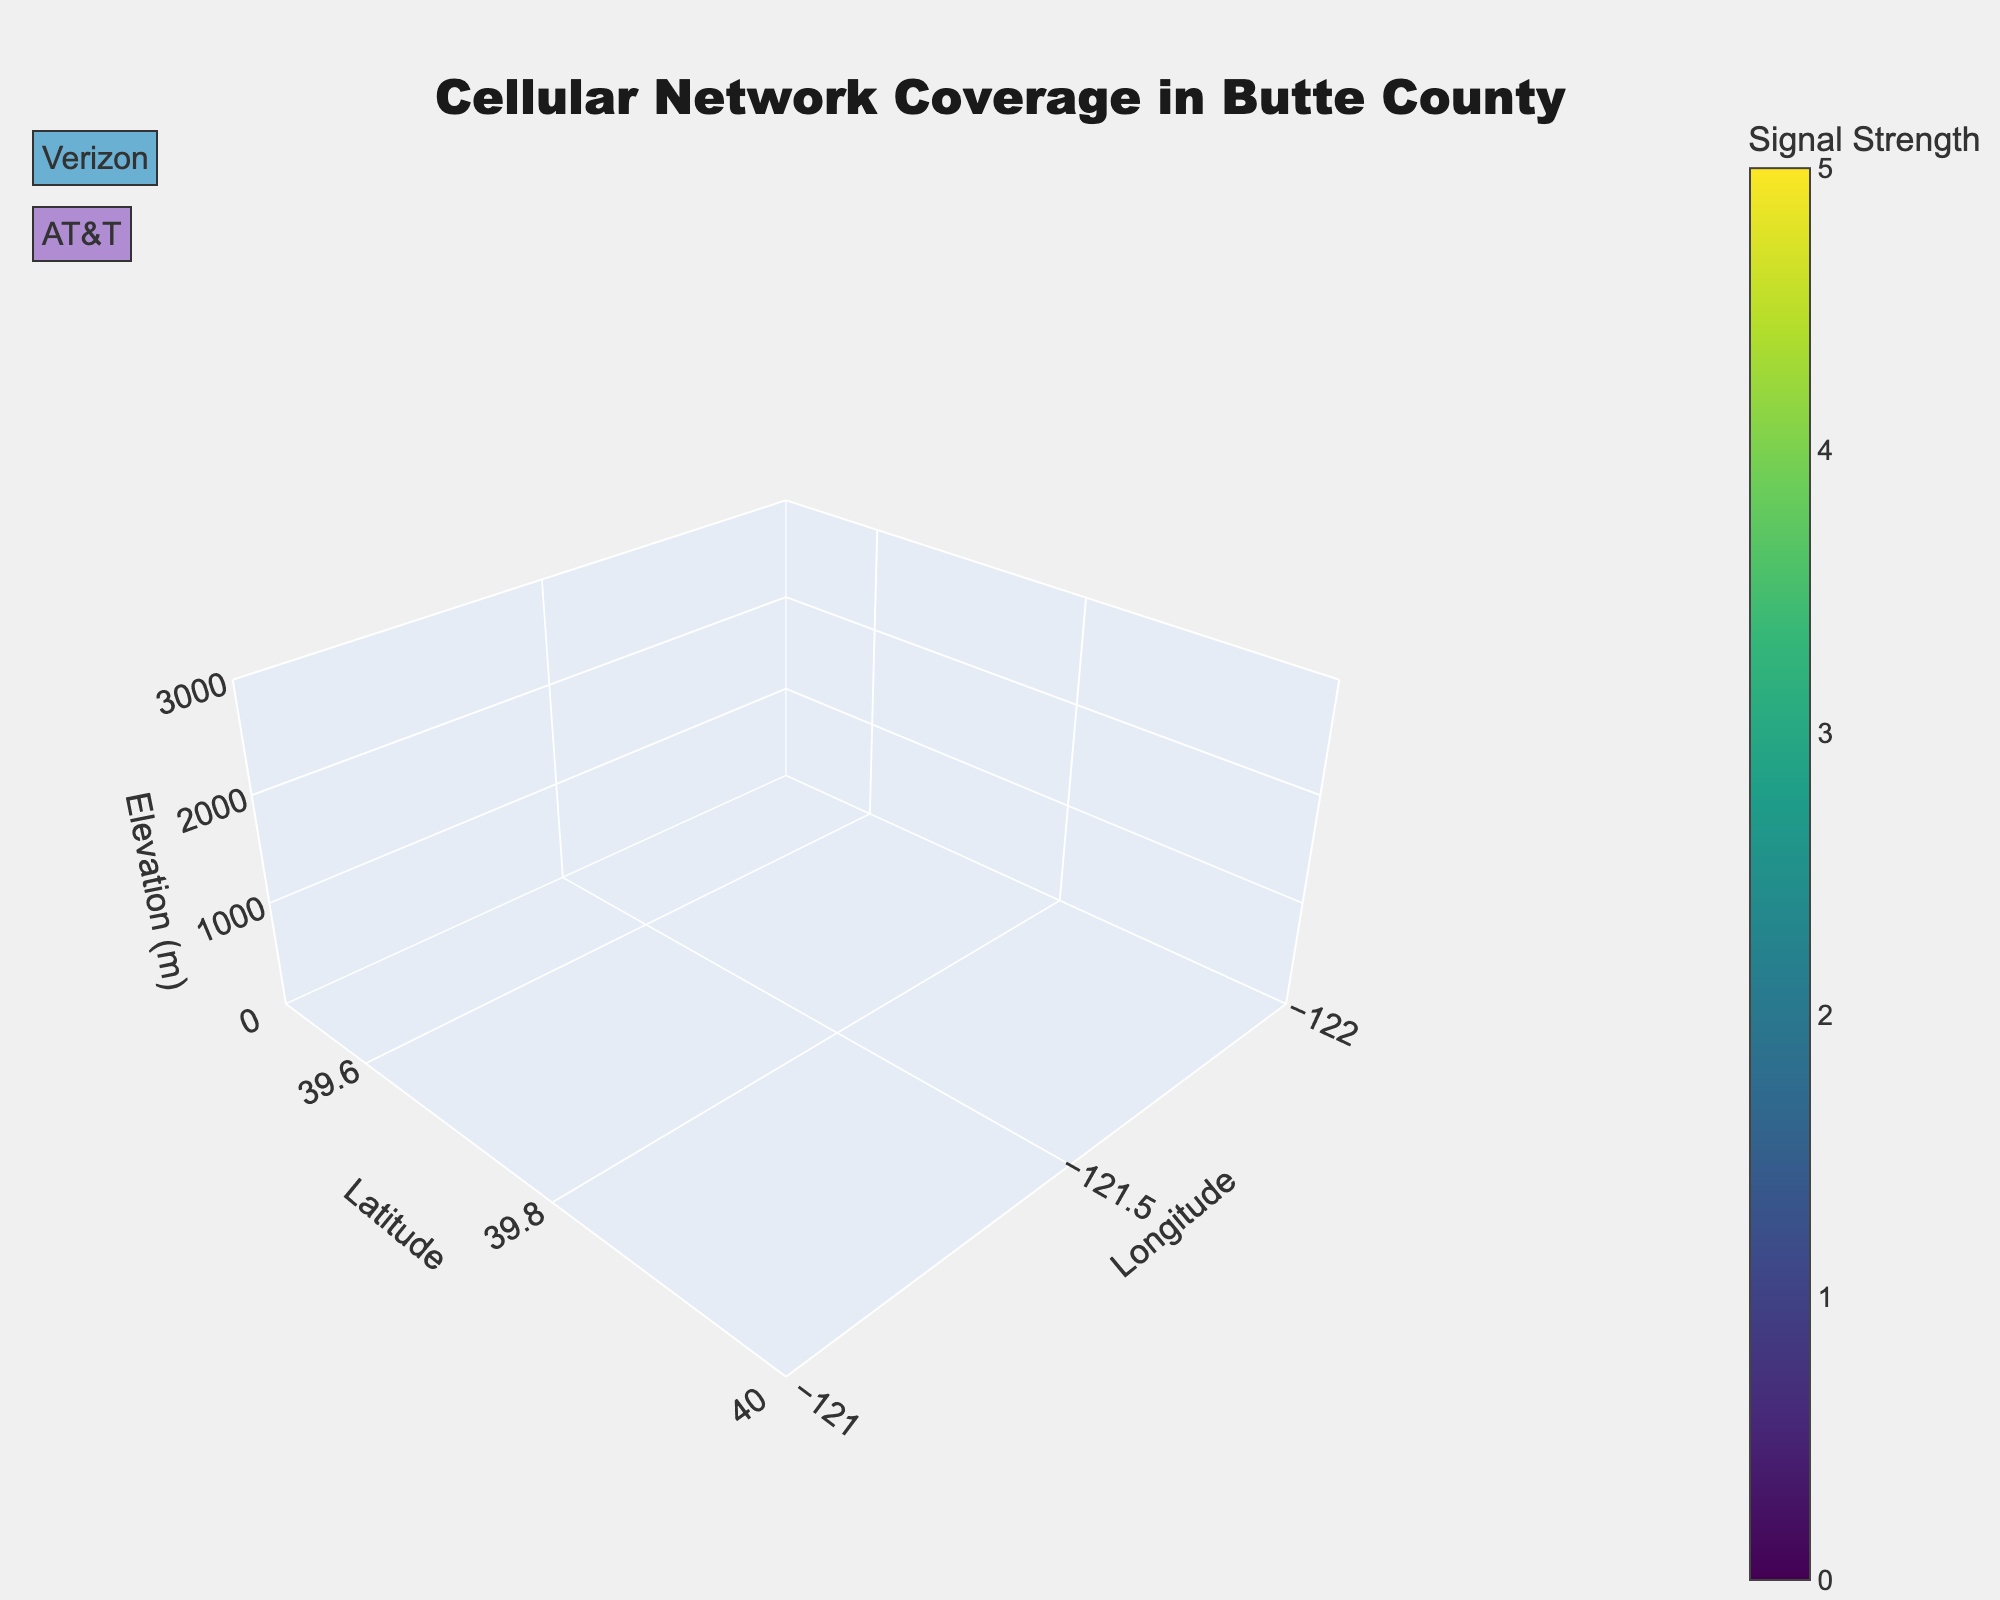What's the title of the figure? The title can be found at the top of the figure. It provides a brief description of the primary purpose or content of the figure.
Answer: Cellular Network Coverage in Butte County Which axes correspond to Latitude and Longitude? The axis titles "Latitude" and "Longitude" are indicated on the vertical and horizontal axes of the figure respectively, helping to understand geographic orientation.
Answer: Vertical for Latitude, Horizontal for Longitude What range of Elevation values is covered in the plot? The range of the Elevation values can be observed from the limits set on the z-axis of the plot. The legends or axis ticks might provide these details.
Answer: 0 to 3000 meters Which cellular provider has the overall weakest signal strength at the highest elevation? Observing the color gradients and signal strength values at different elevations, particularly at higher elevations, can help determine which provider has weaker coverage.
Answer: Verizon What is the average signal strength for AT&T at 200 meters elevation? Sum the signal strengths for AT&T at 200 meters elevation and then divide by the number of data points (2). Signal strengths are 4 and 4, so (4+4)/2=4.
Answer: 4 Which provider has better coverage in the area around 39.6944 Latitude and -121.2861 Longitude at lower elevations? By examining the signal strength values and color gradients for the specified coordinates at lower elevations (2100 meters), we can compare the providers: AT&T has 3, whereas Verizon has 2.
Answer: AT&T How does the signal strength of Verizon at 700 meters elevation compare to AT&T at the same elevation for coordinates 39.5833, -121.4333? Compare the specified signal strengths: Verizon has a signal strength of 2 at 700 meters, while AT&T has a signal strength of 1.
Answer: Verizon has a stronger signal What colors indicate the highest and lowest signal strengths in the figure, and what signal strengths do they represent? The color bar for signal strength indicates the gradient, where darker colors usually correspond to lower values and brighter colors to higher values, commonly with gradients like 'Viridis'.
Answer: Bright color for highest (5), Dark color for lowest (0) How does the signal strength vary with elevation for both providers in the area around 39.7250, -121.8333 Longitude? Observe the data points corresponding to different elevations: For Verizon, the signal strength decreases from 5 to 3, and for AT&T, it decreases from 4 to 2 as elevation increases from 200 to 600 meters.
Answer: Both providers show decreasing signal strength with increasing elevation In which area, considering latitude and longitude, do you observe the highest signal strengths for both providers at any elevation? By identifying the coordinates with the highest signal strengths, we can determine it: 39.7250 Latitude and -121.8333 Longitude have the highest signal strengths of 5 (Verizon) and 4 (AT&T) at lower elevations.
Answer: Around 39.7250 Latitude and -121.8333 Longitude 